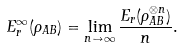<formula> <loc_0><loc_0><loc_500><loc_500>E _ { r } ^ { \infty } ( \rho _ { A B } ) = \lim _ { n \to \infty } \frac { E _ { r } ( \rho _ { A B } ^ { \otimes n } ) } { n } .</formula> 